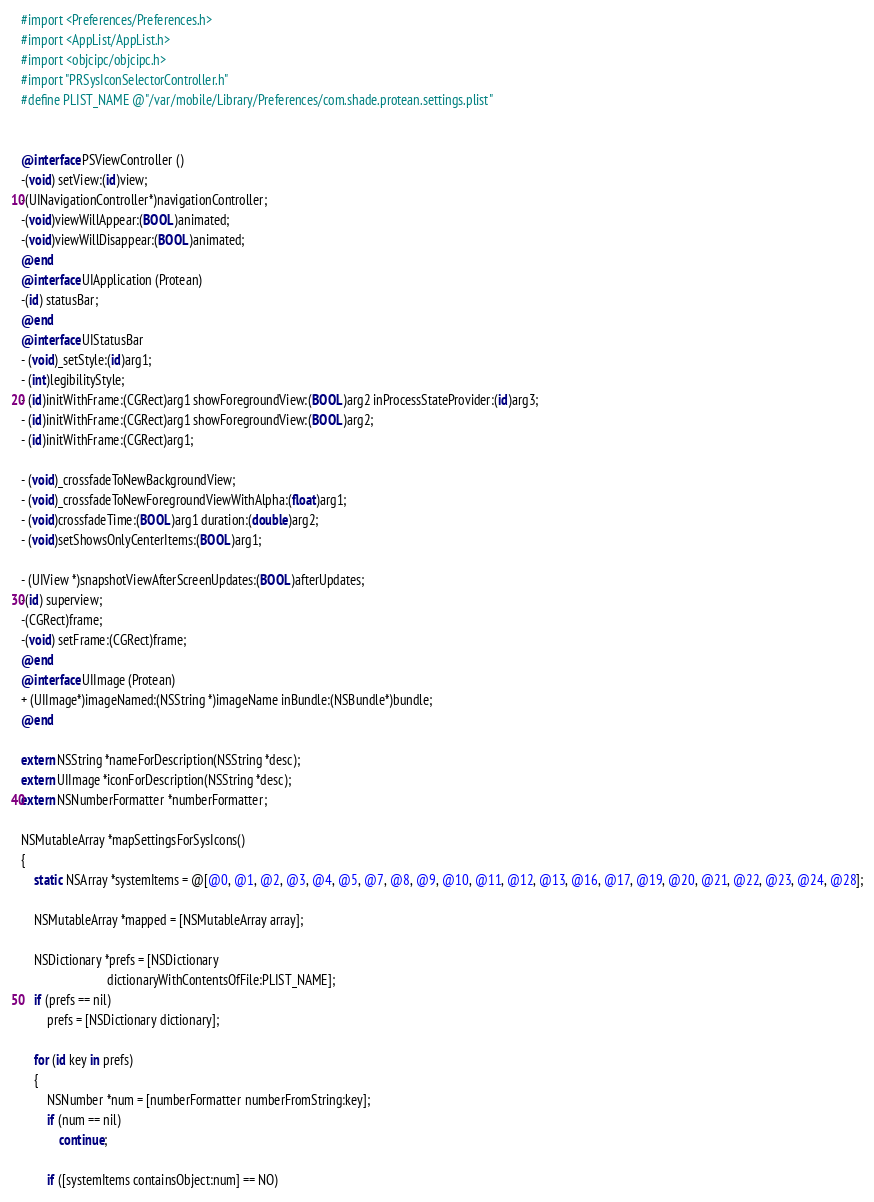Convert code to text. <code><loc_0><loc_0><loc_500><loc_500><_ObjectiveC_>#import <Preferences/Preferences.h>
#import <AppList/AppList.h>
#import <objcipc/objcipc.h>
#import "PRSysIconSelectorController.h"
#define PLIST_NAME @"/var/mobile/Library/Preferences/com.shade.protean.settings.plist"


@interface PSViewController ()
-(void) setView:(id)view;
-(UINavigationController*)navigationController;
-(void)viewWillAppear:(BOOL)animated;
-(void)viewWillDisappear:(BOOL)animated;
@end
@interface UIApplication (Protean)
-(id) statusBar;
@end
@interface UIStatusBar
- (void)_setStyle:(id)arg1;
- (int)legibilityStyle;
- (id)initWithFrame:(CGRect)arg1 showForegroundView:(BOOL)arg2 inProcessStateProvider:(id)arg3;
- (id)initWithFrame:(CGRect)arg1 showForegroundView:(BOOL)arg2;
- (id)initWithFrame:(CGRect)arg1;

- (void)_crossfadeToNewBackgroundView;
- (void)_crossfadeToNewForegroundViewWithAlpha:(float)arg1;
- (void)crossfadeTime:(BOOL)arg1 duration:(double)arg2;
- (void)setShowsOnlyCenterItems:(BOOL)arg1;

- (UIView *)snapshotViewAfterScreenUpdates:(BOOL)afterUpdates;
-(id) superview;
-(CGRect)frame;
-(void) setFrame:(CGRect)frame;
@end
@interface UIImage (Protean)
+ (UIImage*)imageNamed:(NSString *)imageName inBundle:(NSBundle*)bundle;
@end

extern NSString *nameForDescription(NSString *desc);
extern UIImage *iconForDescription(NSString *desc);
extern NSNumberFormatter *numberFormatter;

NSMutableArray *mapSettingsForSysIcons()
{
    static NSArray *systemItems = @[@0, @1, @2, @3, @4, @5, @7, @8, @9, @10, @11, @12, @13, @16, @17, @19, @20, @21, @22, @23, @24, @28];

    NSMutableArray *mapped = [NSMutableArray array];

    NSDictionary *prefs = [NSDictionary
                           dictionaryWithContentsOfFile:PLIST_NAME];
    if (prefs == nil)
        prefs = [NSDictionary dictionary];

    for (id key in prefs)
    {
        NSNumber *num = [numberFormatter numberFromString:key];
        if (num == nil)
            continue;

        if ([systemItems containsObject:num] == NO)</code> 